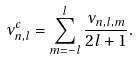Convert formula to latex. <formula><loc_0><loc_0><loc_500><loc_500>\nu ^ { c } _ { n , l } = \sum ^ { l } _ { m = - l } \frac { \nu _ { n , l , m } } { 2 l + 1 } .</formula> 